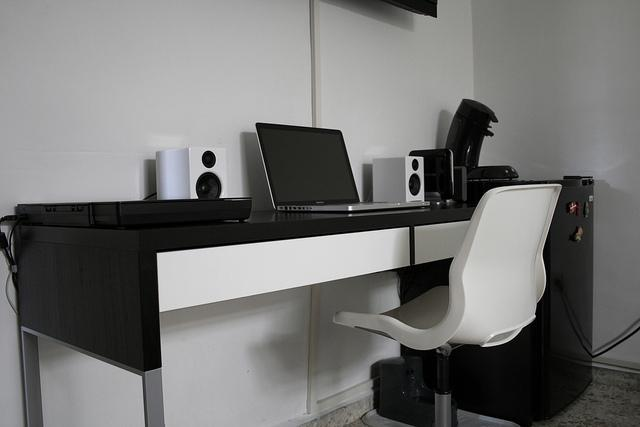Which object in the room can create the most noise? Please explain your reasoning. speakers. Sound comes from speakers. 